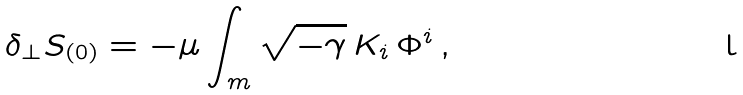<formula> <loc_0><loc_0><loc_500><loc_500>\delta _ { \perp } S _ { ( 0 ) } = - \mu \int _ { m } \sqrt { - \gamma } \, K _ { i } \, \Phi ^ { i } \, ,</formula> 